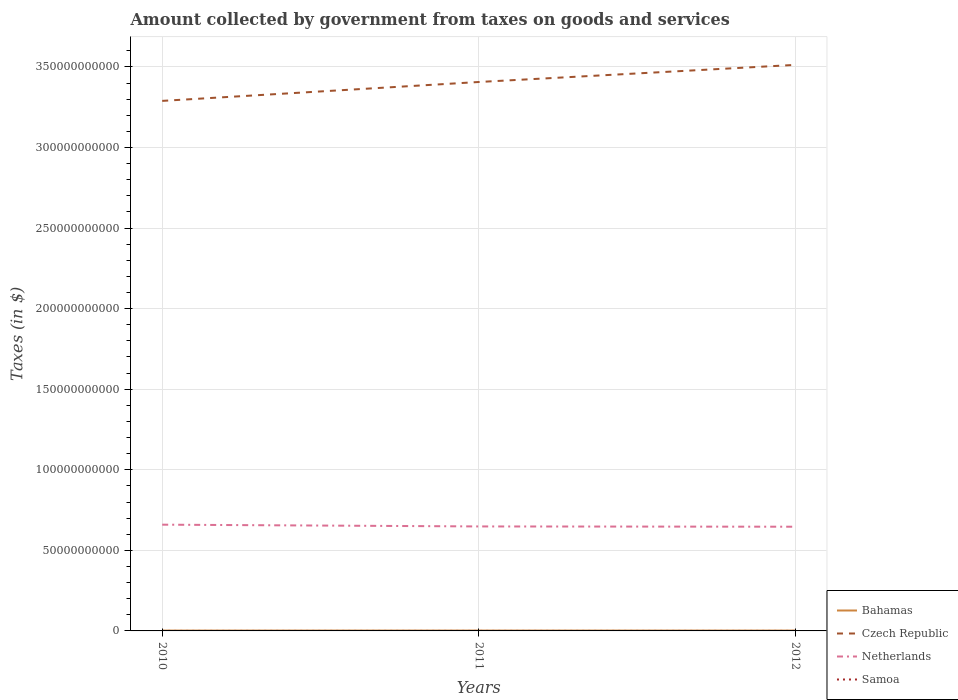Does the line corresponding to Samoa intersect with the line corresponding to Bahamas?
Your answer should be compact. No. Is the number of lines equal to the number of legend labels?
Ensure brevity in your answer.  Yes. Across all years, what is the maximum amount collected by government from taxes on goods and services in Bahamas?
Offer a terse response. 2.08e+08. In which year was the amount collected by government from taxes on goods and services in Czech Republic maximum?
Keep it short and to the point. 2010. What is the total amount collected by government from taxes on goods and services in Czech Republic in the graph?
Offer a very short reply. -2.23e+1. What is the difference between the highest and the second highest amount collected by government from taxes on goods and services in Czech Republic?
Provide a succinct answer. 2.23e+1. What is the difference between the highest and the lowest amount collected by government from taxes on goods and services in Samoa?
Give a very brief answer. 2. Is the amount collected by government from taxes on goods and services in Samoa strictly greater than the amount collected by government from taxes on goods and services in Netherlands over the years?
Give a very brief answer. Yes. How many lines are there?
Offer a terse response. 4. How many years are there in the graph?
Provide a short and direct response. 3. Are the values on the major ticks of Y-axis written in scientific E-notation?
Offer a terse response. No. How many legend labels are there?
Provide a short and direct response. 4. How are the legend labels stacked?
Offer a terse response. Vertical. What is the title of the graph?
Provide a short and direct response. Amount collected by government from taxes on goods and services. What is the label or title of the X-axis?
Offer a very short reply. Years. What is the label or title of the Y-axis?
Offer a very short reply. Taxes (in $). What is the Taxes (in $) in Bahamas in 2010?
Offer a very short reply. 2.08e+08. What is the Taxes (in $) in Czech Republic in 2010?
Your response must be concise. 3.29e+11. What is the Taxes (in $) of Netherlands in 2010?
Your answer should be compact. 6.59e+1. What is the Taxes (in $) of Samoa in 2010?
Offer a very short reply. 2.36e+05. What is the Taxes (in $) of Bahamas in 2011?
Make the answer very short. 2.20e+08. What is the Taxes (in $) in Czech Republic in 2011?
Offer a terse response. 3.41e+11. What is the Taxes (in $) of Netherlands in 2011?
Provide a succinct answer. 6.48e+1. What is the Taxes (in $) in Samoa in 2011?
Your answer should be very brief. 2.38e+05. What is the Taxes (in $) of Bahamas in 2012?
Your answer should be very brief. 2.09e+08. What is the Taxes (in $) of Czech Republic in 2012?
Keep it short and to the point. 3.51e+11. What is the Taxes (in $) in Netherlands in 2012?
Offer a terse response. 6.47e+1. What is the Taxes (in $) of Samoa in 2012?
Offer a terse response. 2.32e+05. Across all years, what is the maximum Taxes (in $) of Bahamas?
Keep it short and to the point. 2.20e+08. Across all years, what is the maximum Taxes (in $) in Czech Republic?
Provide a short and direct response. 3.51e+11. Across all years, what is the maximum Taxes (in $) in Netherlands?
Give a very brief answer. 6.59e+1. Across all years, what is the maximum Taxes (in $) in Samoa?
Your answer should be very brief. 2.38e+05. Across all years, what is the minimum Taxes (in $) of Bahamas?
Provide a short and direct response. 2.08e+08. Across all years, what is the minimum Taxes (in $) of Czech Republic?
Ensure brevity in your answer.  3.29e+11. Across all years, what is the minimum Taxes (in $) in Netherlands?
Make the answer very short. 6.47e+1. Across all years, what is the minimum Taxes (in $) of Samoa?
Ensure brevity in your answer.  2.32e+05. What is the total Taxes (in $) of Bahamas in the graph?
Your response must be concise. 6.37e+08. What is the total Taxes (in $) in Czech Republic in the graph?
Ensure brevity in your answer.  1.02e+12. What is the total Taxes (in $) of Netherlands in the graph?
Offer a very short reply. 1.95e+11. What is the total Taxes (in $) in Samoa in the graph?
Your answer should be very brief. 7.06e+05. What is the difference between the Taxes (in $) of Bahamas in 2010 and that in 2011?
Provide a short and direct response. -1.13e+07. What is the difference between the Taxes (in $) of Czech Republic in 2010 and that in 2011?
Provide a succinct answer. -1.17e+1. What is the difference between the Taxes (in $) of Netherlands in 2010 and that in 2011?
Make the answer very short. 1.10e+09. What is the difference between the Taxes (in $) in Samoa in 2010 and that in 2011?
Your response must be concise. -1013.36. What is the difference between the Taxes (in $) of Bahamas in 2010 and that in 2012?
Offer a very short reply. -2.25e+05. What is the difference between the Taxes (in $) in Czech Republic in 2010 and that in 2012?
Your answer should be very brief. -2.23e+1. What is the difference between the Taxes (in $) of Netherlands in 2010 and that in 2012?
Offer a terse response. 1.27e+09. What is the difference between the Taxes (in $) of Samoa in 2010 and that in 2012?
Offer a terse response. 4110.08. What is the difference between the Taxes (in $) of Bahamas in 2011 and that in 2012?
Keep it short and to the point. 1.11e+07. What is the difference between the Taxes (in $) of Czech Republic in 2011 and that in 2012?
Ensure brevity in your answer.  -1.06e+1. What is the difference between the Taxes (in $) of Netherlands in 2011 and that in 2012?
Provide a short and direct response. 1.69e+08. What is the difference between the Taxes (in $) of Samoa in 2011 and that in 2012?
Ensure brevity in your answer.  5123.44. What is the difference between the Taxes (in $) of Bahamas in 2010 and the Taxes (in $) of Czech Republic in 2011?
Your answer should be compact. -3.40e+11. What is the difference between the Taxes (in $) in Bahamas in 2010 and the Taxes (in $) in Netherlands in 2011?
Offer a very short reply. -6.46e+1. What is the difference between the Taxes (in $) in Bahamas in 2010 and the Taxes (in $) in Samoa in 2011?
Make the answer very short. 2.08e+08. What is the difference between the Taxes (in $) in Czech Republic in 2010 and the Taxes (in $) in Netherlands in 2011?
Offer a terse response. 2.64e+11. What is the difference between the Taxes (in $) in Czech Republic in 2010 and the Taxes (in $) in Samoa in 2011?
Your response must be concise. 3.29e+11. What is the difference between the Taxes (in $) in Netherlands in 2010 and the Taxes (in $) in Samoa in 2011?
Your answer should be very brief. 6.59e+1. What is the difference between the Taxes (in $) in Bahamas in 2010 and the Taxes (in $) in Czech Republic in 2012?
Ensure brevity in your answer.  -3.51e+11. What is the difference between the Taxes (in $) in Bahamas in 2010 and the Taxes (in $) in Netherlands in 2012?
Ensure brevity in your answer.  -6.45e+1. What is the difference between the Taxes (in $) in Bahamas in 2010 and the Taxes (in $) in Samoa in 2012?
Your answer should be compact. 2.08e+08. What is the difference between the Taxes (in $) in Czech Republic in 2010 and the Taxes (in $) in Netherlands in 2012?
Offer a terse response. 2.64e+11. What is the difference between the Taxes (in $) of Czech Republic in 2010 and the Taxes (in $) of Samoa in 2012?
Offer a terse response. 3.29e+11. What is the difference between the Taxes (in $) of Netherlands in 2010 and the Taxes (in $) of Samoa in 2012?
Your answer should be very brief. 6.59e+1. What is the difference between the Taxes (in $) in Bahamas in 2011 and the Taxes (in $) in Czech Republic in 2012?
Give a very brief answer. -3.51e+11. What is the difference between the Taxes (in $) in Bahamas in 2011 and the Taxes (in $) in Netherlands in 2012?
Provide a succinct answer. -6.44e+1. What is the difference between the Taxes (in $) of Bahamas in 2011 and the Taxes (in $) of Samoa in 2012?
Make the answer very short. 2.20e+08. What is the difference between the Taxes (in $) of Czech Republic in 2011 and the Taxes (in $) of Netherlands in 2012?
Your answer should be very brief. 2.76e+11. What is the difference between the Taxes (in $) of Czech Republic in 2011 and the Taxes (in $) of Samoa in 2012?
Your answer should be very brief. 3.41e+11. What is the difference between the Taxes (in $) of Netherlands in 2011 and the Taxes (in $) of Samoa in 2012?
Offer a terse response. 6.48e+1. What is the average Taxes (in $) in Bahamas per year?
Your answer should be compact. 2.12e+08. What is the average Taxes (in $) in Czech Republic per year?
Keep it short and to the point. 3.40e+11. What is the average Taxes (in $) in Netherlands per year?
Give a very brief answer. 6.51e+1. What is the average Taxes (in $) of Samoa per year?
Offer a very short reply. 2.35e+05. In the year 2010, what is the difference between the Taxes (in $) in Bahamas and Taxes (in $) in Czech Republic?
Make the answer very short. -3.29e+11. In the year 2010, what is the difference between the Taxes (in $) in Bahamas and Taxes (in $) in Netherlands?
Provide a short and direct response. -6.57e+1. In the year 2010, what is the difference between the Taxes (in $) of Bahamas and Taxes (in $) of Samoa?
Your answer should be very brief. 2.08e+08. In the year 2010, what is the difference between the Taxes (in $) of Czech Republic and Taxes (in $) of Netherlands?
Make the answer very short. 2.63e+11. In the year 2010, what is the difference between the Taxes (in $) of Czech Republic and Taxes (in $) of Samoa?
Your answer should be compact. 3.29e+11. In the year 2010, what is the difference between the Taxes (in $) of Netherlands and Taxes (in $) of Samoa?
Make the answer very short. 6.59e+1. In the year 2011, what is the difference between the Taxes (in $) in Bahamas and Taxes (in $) in Czech Republic?
Your response must be concise. -3.40e+11. In the year 2011, what is the difference between the Taxes (in $) in Bahamas and Taxes (in $) in Netherlands?
Your answer should be very brief. -6.46e+1. In the year 2011, what is the difference between the Taxes (in $) in Bahamas and Taxes (in $) in Samoa?
Provide a succinct answer. 2.20e+08. In the year 2011, what is the difference between the Taxes (in $) of Czech Republic and Taxes (in $) of Netherlands?
Ensure brevity in your answer.  2.76e+11. In the year 2011, what is the difference between the Taxes (in $) in Czech Republic and Taxes (in $) in Samoa?
Offer a terse response. 3.41e+11. In the year 2011, what is the difference between the Taxes (in $) in Netherlands and Taxes (in $) in Samoa?
Your answer should be very brief. 6.48e+1. In the year 2012, what is the difference between the Taxes (in $) in Bahamas and Taxes (in $) in Czech Republic?
Offer a terse response. -3.51e+11. In the year 2012, what is the difference between the Taxes (in $) of Bahamas and Taxes (in $) of Netherlands?
Ensure brevity in your answer.  -6.45e+1. In the year 2012, what is the difference between the Taxes (in $) of Bahamas and Taxes (in $) of Samoa?
Provide a succinct answer. 2.08e+08. In the year 2012, what is the difference between the Taxes (in $) in Czech Republic and Taxes (in $) in Netherlands?
Your response must be concise. 2.87e+11. In the year 2012, what is the difference between the Taxes (in $) of Czech Republic and Taxes (in $) of Samoa?
Ensure brevity in your answer.  3.51e+11. In the year 2012, what is the difference between the Taxes (in $) in Netherlands and Taxes (in $) in Samoa?
Provide a succinct answer. 6.47e+1. What is the ratio of the Taxes (in $) in Bahamas in 2010 to that in 2011?
Offer a terse response. 0.95. What is the ratio of the Taxes (in $) of Czech Republic in 2010 to that in 2011?
Provide a succinct answer. 0.97. What is the ratio of the Taxes (in $) in Bahamas in 2010 to that in 2012?
Make the answer very short. 1. What is the ratio of the Taxes (in $) in Czech Republic in 2010 to that in 2012?
Offer a very short reply. 0.94. What is the ratio of the Taxes (in $) in Netherlands in 2010 to that in 2012?
Provide a succinct answer. 1.02. What is the ratio of the Taxes (in $) of Samoa in 2010 to that in 2012?
Your response must be concise. 1.02. What is the ratio of the Taxes (in $) of Bahamas in 2011 to that in 2012?
Provide a short and direct response. 1.05. What is the ratio of the Taxes (in $) of Czech Republic in 2011 to that in 2012?
Ensure brevity in your answer.  0.97. What is the ratio of the Taxes (in $) of Samoa in 2011 to that in 2012?
Your response must be concise. 1.02. What is the difference between the highest and the second highest Taxes (in $) in Bahamas?
Give a very brief answer. 1.11e+07. What is the difference between the highest and the second highest Taxes (in $) in Czech Republic?
Provide a succinct answer. 1.06e+1. What is the difference between the highest and the second highest Taxes (in $) of Netherlands?
Keep it short and to the point. 1.10e+09. What is the difference between the highest and the second highest Taxes (in $) in Samoa?
Your response must be concise. 1013.36. What is the difference between the highest and the lowest Taxes (in $) of Bahamas?
Give a very brief answer. 1.13e+07. What is the difference between the highest and the lowest Taxes (in $) of Czech Republic?
Your response must be concise. 2.23e+1. What is the difference between the highest and the lowest Taxes (in $) of Netherlands?
Offer a very short reply. 1.27e+09. What is the difference between the highest and the lowest Taxes (in $) of Samoa?
Provide a short and direct response. 5123.44. 